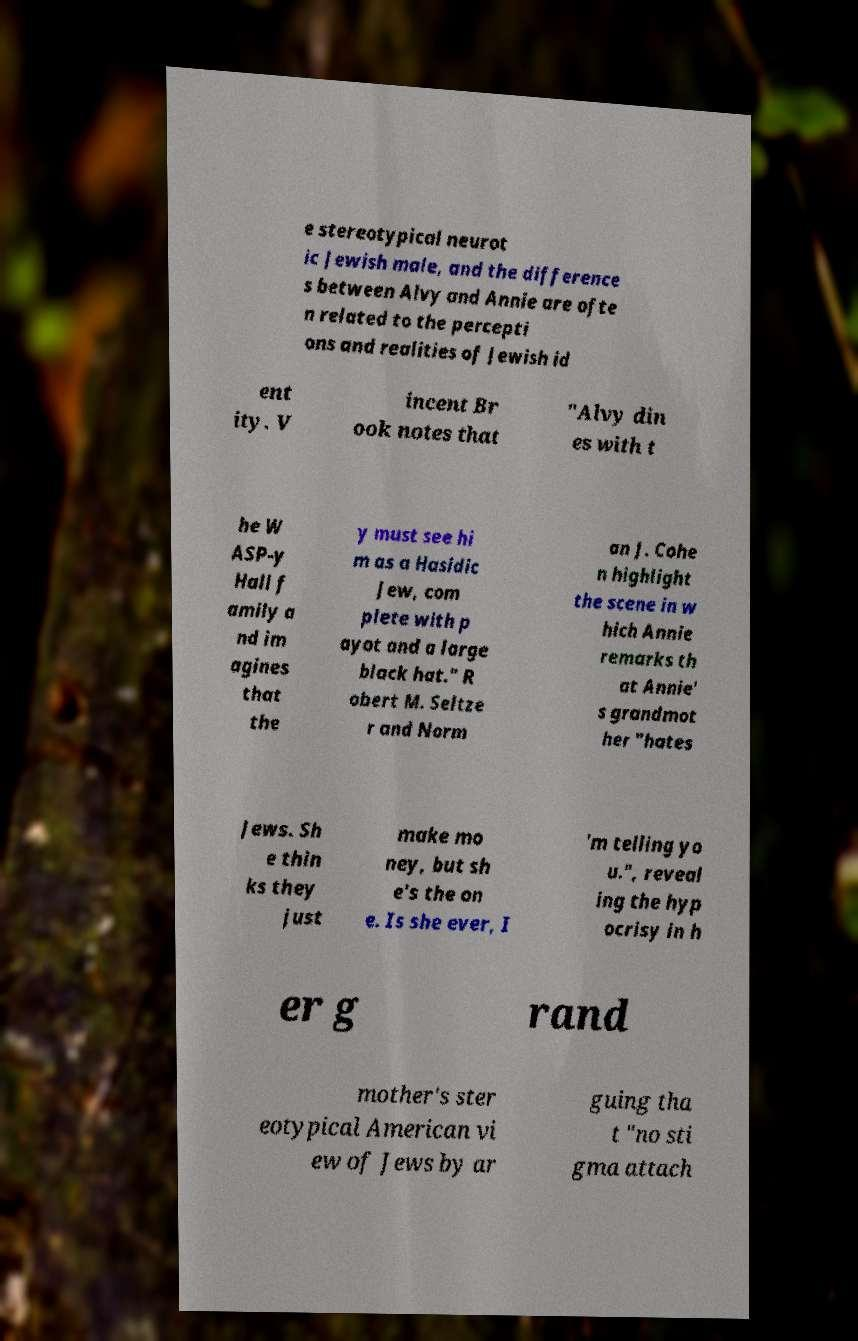Please read and relay the text visible in this image. What does it say? e stereotypical neurot ic Jewish male, and the difference s between Alvy and Annie are ofte n related to the percepti ons and realities of Jewish id ent ity. V incent Br ook notes that "Alvy din es with t he W ASP-y Hall f amily a nd im agines that the y must see hi m as a Hasidic Jew, com plete with p ayot and a large black hat." R obert M. Seltze r and Norm an J. Cohe n highlight the scene in w hich Annie remarks th at Annie' s grandmot her "hates Jews. Sh e thin ks they just make mo ney, but sh e's the on e. Is she ever, I 'm telling yo u.", reveal ing the hyp ocrisy in h er g rand mother's ster eotypical American vi ew of Jews by ar guing tha t "no sti gma attach 